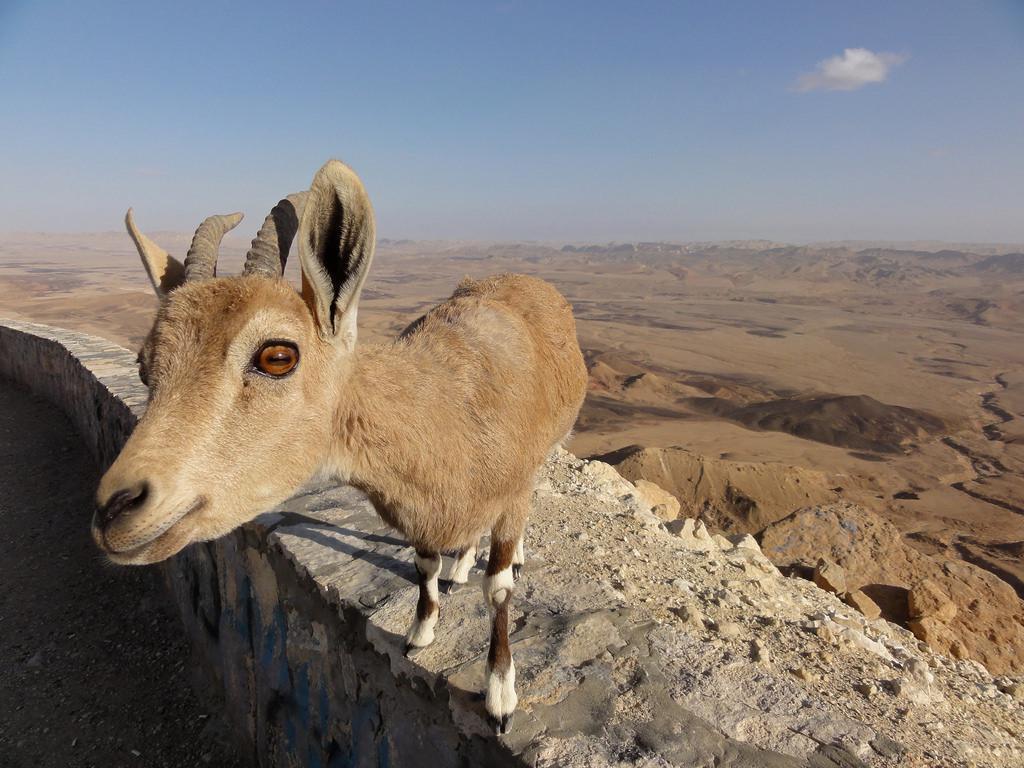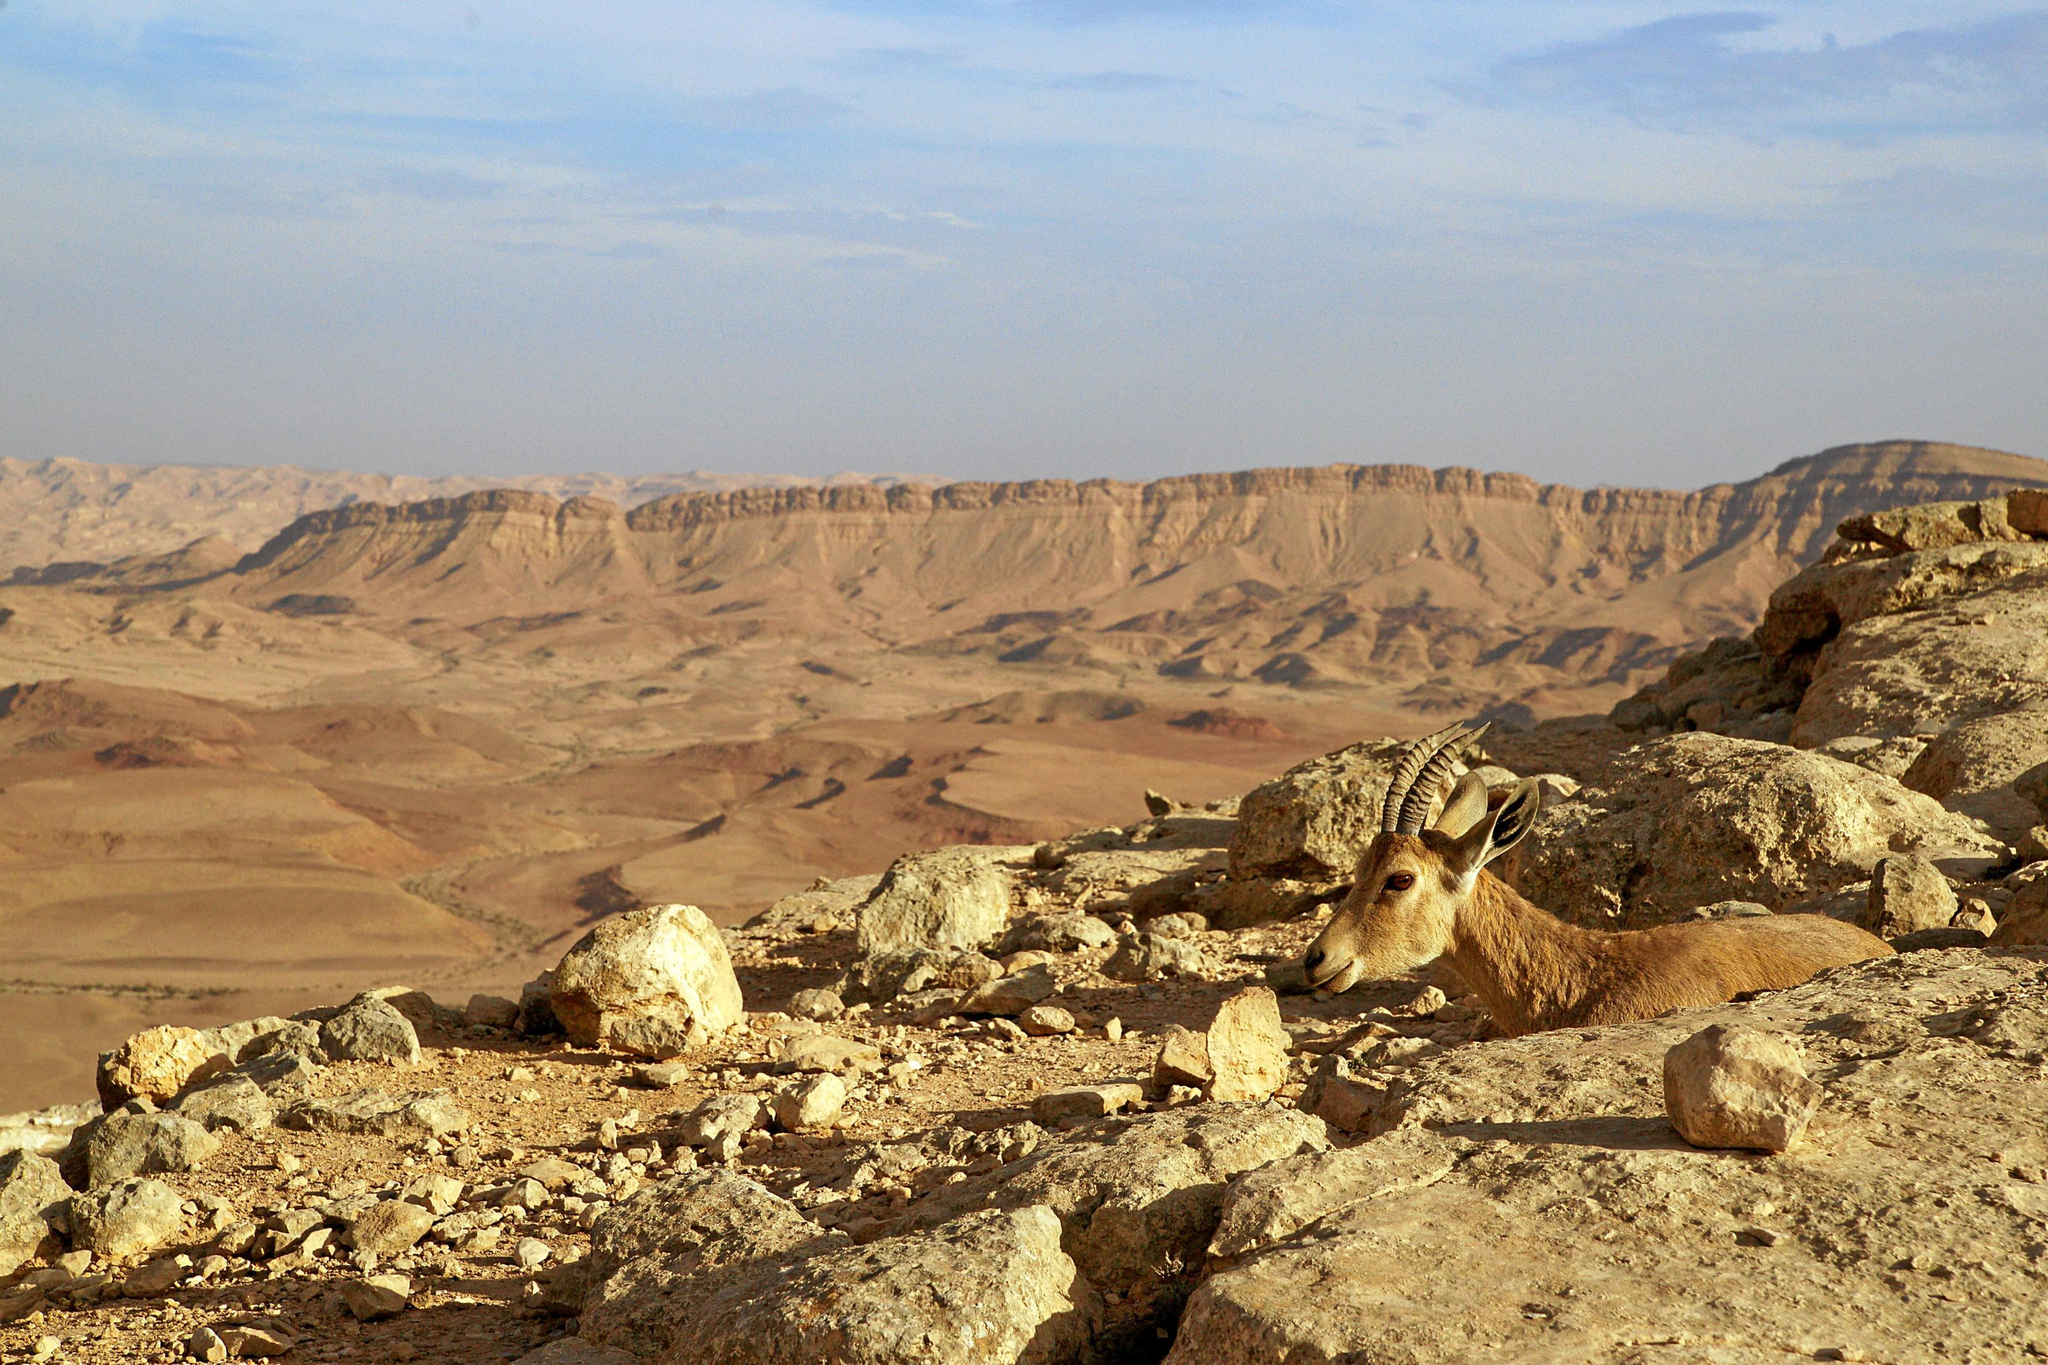The first image is the image on the left, the second image is the image on the right. Given the left and right images, does the statement "A single animal is standing on a rocky area in the image on the left." hold true? Answer yes or no. Yes. 